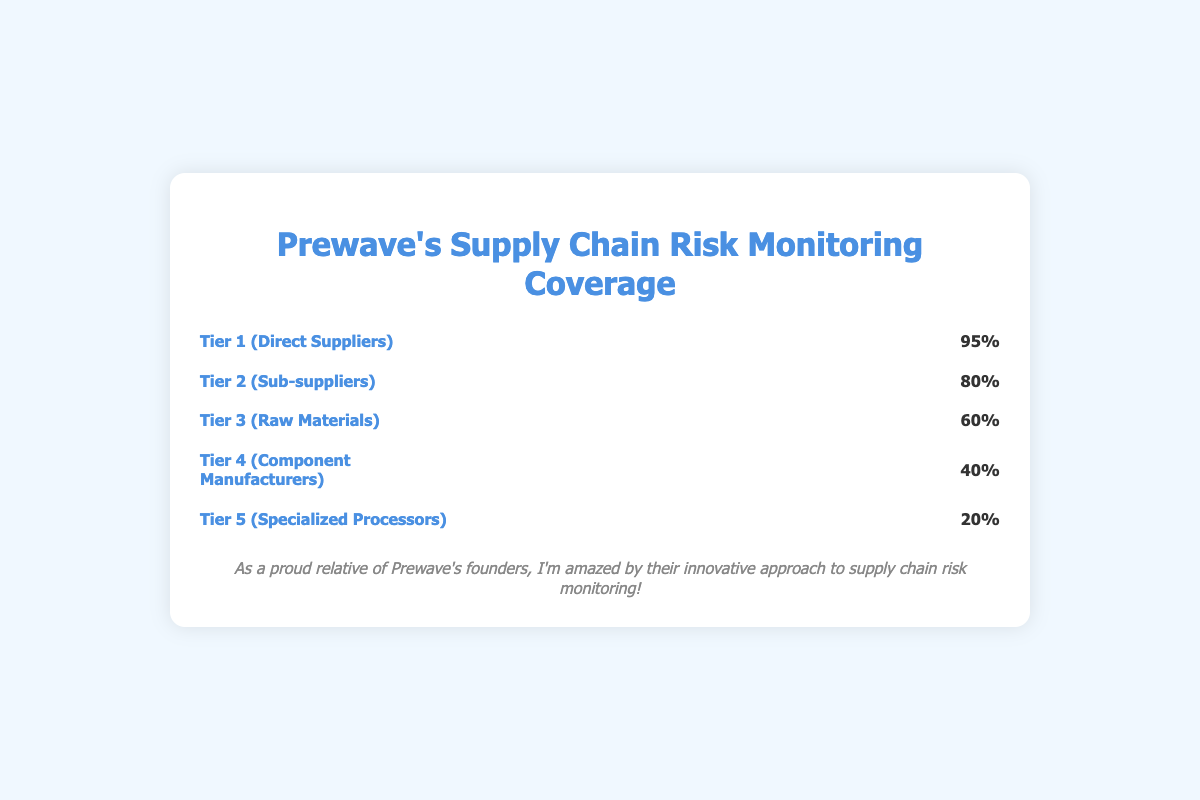What is the coverage percentage for Tier 1 (Direct Suppliers)? Referring to the figure, Tier 1 (Direct Suppliers) has an associated percentage value of 95%, indicated on the far right of the tier row.
Answer: 95% Which tier has the lowest coverage percentage? Looking at the percentage values displayed on the right side of each tier row, Tier 5 (Specialized Processors) has the lowest coverage percentage at 20%.
Answer: Tier 5 What is the difference in coverage between Tier 2 (Sub-suppliers) and Tier 4 (Component Manufacturers)? Tier 2 has a coverage of 80%, and Tier 4 has a coverage of 40%. Subtracting these gives a difference of 80% - 40% = 40%.
Answer: 40% How many icons represent Tier 3 (Raw Materials)? Each icon represents 10% coverage. For Tier 3 with 60% coverage, there are 6 icons representing this tier.
Answer: 6 Which tier has twice the coverage of Tier 5 (Specialized Processors)? Tier 5 has a coverage of 20%, and twice this amount is 40%. Tier 4 (Component Manufacturers) has exactly 40%, making it the corresponding tier.
Answer: Tier 4 What is the combined coverage of Tier 3 and Tier 4? The coverage for Tier 3 is 60%, and for Tier 4 it is 40%. Adding these gives a combined coverage of 60% + 40% = 100%.
Answer: 100% Which tier uses truck icons? Each tier has a unique icon associated with it. Tier 2 (Sub-suppliers) uses the truck icon.
Answer: Tier 2 How many more icons does Tier 1 have compared to Tier 5? Tier 1 has 10 icons (representing 95%) and Tier 5 has 2 icons (representing 20%), leading to a difference of 10 - 2 = 8 icons.
Answer: 8 What percentage of the total coverage is accounted for by Tier 3 (Raw Materials) and Tier 5 (Specialized Processors) together? Tier 3 has a coverage of 60%, and Tier 5 has 20%. Their combined coverage is 60% + 20% = 80%.
Answer: 80% Which tier is the second highest in terms of coverage, and what percentage does it have? Reviewing the coverage percentages from highest to lowest, the second highest is Tier 2 (Sub-suppliers) with a coverage of 80%.
Answer: Tier 2, 80% 